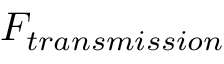Convert formula to latex. <formula><loc_0><loc_0><loc_500><loc_500>F _ { t r a n s m i s s i o n }</formula> 